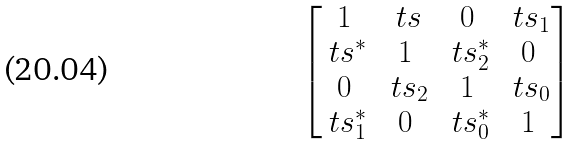Convert formula to latex. <formula><loc_0><loc_0><loc_500><loc_500>\begin{bmatrix} 1 & \ t s & 0 & \ t s _ { 1 } \\ \ t s ^ { * } & 1 & \ t s _ { 2 } ^ { * } & 0 \\ 0 & \ t s _ { 2 } & 1 & \ t s _ { 0 } \\ \ t s _ { 1 } ^ { * } & 0 & \ t s _ { 0 } ^ { * } & 1 \end{bmatrix}</formula> 